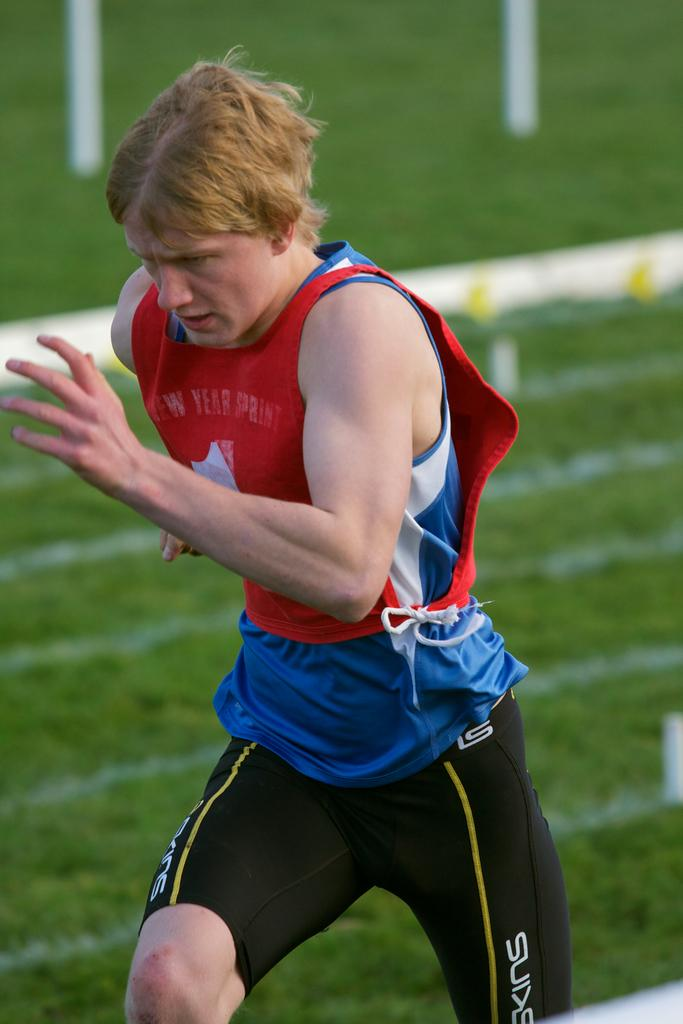<image>
Create a compact narrative representing the image presented. A runner wearing a New Year Sprint jersey races down the track. 